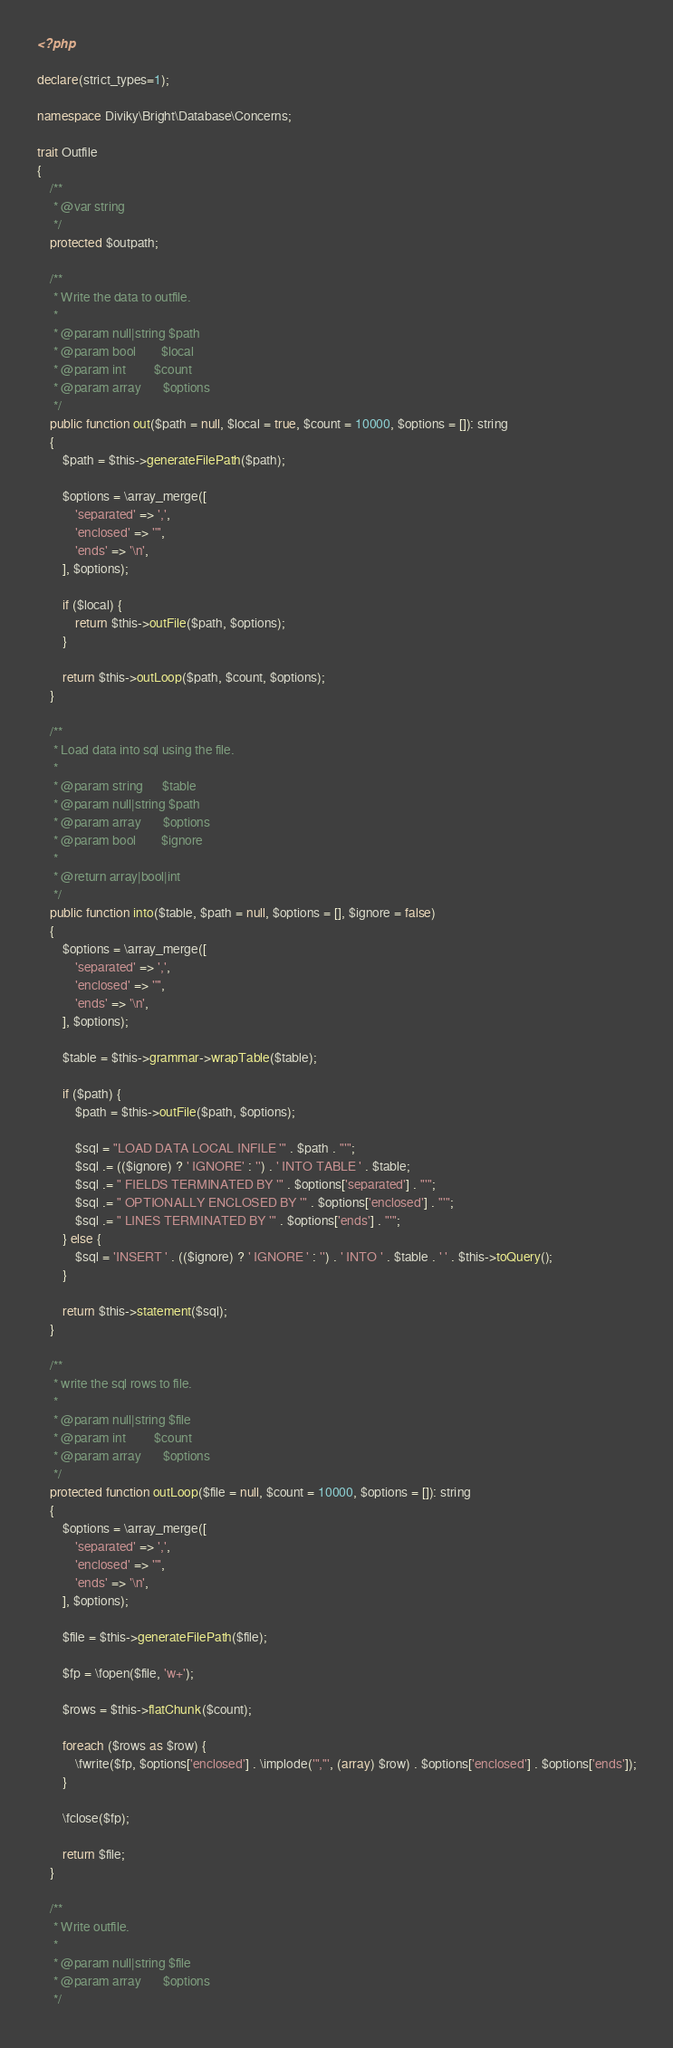Convert code to text. <code><loc_0><loc_0><loc_500><loc_500><_PHP_><?php

declare(strict_types=1);

namespace Diviky\Bright\Database\Concerns;

trait Outfile
{
    /**
     * @var string
     */
    protected $outpath;

    /**
     * Write the data to outfile.
     *
     * @param null|string $path
     * @param bool        $local
     * @param int         $count
     * @param array       $options
     */
    public function out($path = null, $local = true, $count = 10000, $options = []): string
    {
        $path = $this->generateFilePath($path);

        $options = \array_merge([
            'separated' => ',',
            'enclosed' => '"',
            'ends' => '\n',
        ], $options);

        if ($local) {
            return $this->outFile($path, $options);
        }

        return $this->outLoop($path, $count, $options);
    }

    /**
     * Load data into sql using the file.
     *
     * @param string      $table
     * @param null|string $path
     * @param array       $options
     * @param bool        $ignore
     *
     * @return array|bool|int
     */
    public function into($table, $path = null, $options = [], $ignore = false)
    {
        $options = \array_merge([
            'separated' => ',',
            'enclosed' => '"',
            'ends' => '\n',
        ], $options);

        $table = $this->grammar->wrapTable($table);

        if ($path) {
            $path = $this->outFile($path, $options);

            $sql = "LOAD DATA LOCAL INFILE '" . $path . "'";
            $sql .= (($ignore) ? ' IGNORE' : '') . ' INTO TABLE ' . $table;
            $sql .= " FIELDS TERMINATED BY '" . $options['separated'] . "'";
            $sql .= " OPTIONALLY ENCLOSED BY '" . $options['enclosed'] . "'";
            $sql .= " LINES TERMINATED BY '" . $options['ends'] . "'";
        } else {
            $sql = 'INSERT ' . (($ignore) ? ' IGNORE ' : '') . ' INTO ' . $table . ' ' . $this->toQuery();
        }

        return $this->statement($sql);
    }

    /**
     * write the sql rows to file.
     *
     * @param null|string $file
     * @param int         $count
     * @param array       $options
     */
    protected function outLoop($file = null, $count = 10000, $options = []): string
    {
        $options = \array_merge([
            'separated' => ',',
            'enclosed' => '"',
            'ends' => '\n',
        ], $options);

        $file = $this->generateFilePath($file);

        $fp = \fopen($file, 'w+');

        $rows = $this->flatChunk($count);

        foreach ($rows as $row) {
            \fwrite($fp, $options['enclosed'] . \implode('","', (array) $row) . $options['enclosed'] . $options['ends']);
        }

        \fclose($fp);

        return $file;
    }

    /**
     * Write outfile.
     *
     * @param null|string $file
     * @param array       $options
     */</code> 